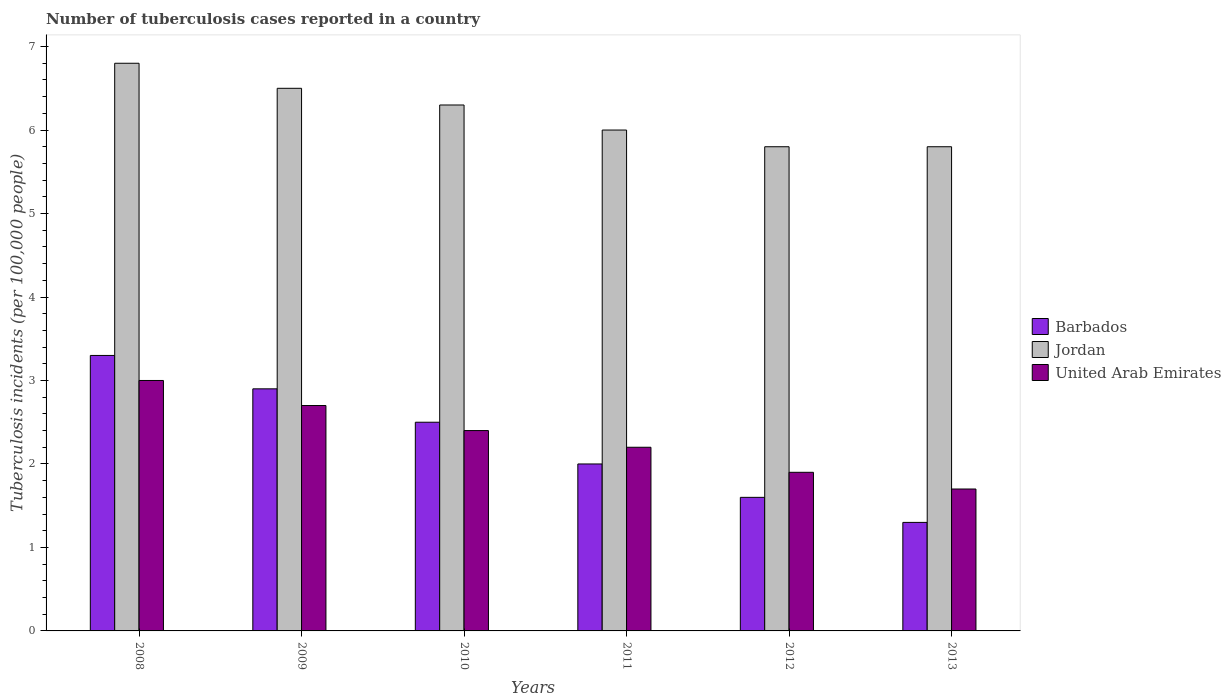How many different coloured bars are there?
Provide a succinct answer. 3. How many groups of bars are there?
Make the answer very short. 6. Are the number of bars per tick equal to the number of legend labels?
Keep it short and to the point. Yes. Are the number of bars on each tick of the X-axis equal?
Make the answer very short. Yes. How many bars are there on the 5th tick from the right?
Ensure brevity in your answer.  3. In how many cases, is the number of bars for a given year not equal to the number of legend labels?
Ensure brevity in your answer.  0. Across all years, what is the maximum number of tuberculosis cases reported in in Barbados?
Your answer should be compact. 3.3. Across all years, what is the minimum number of tuberculosis cases reported in in United Arab Emirates?
Give a very brief answer. 1.7. In which year was the number of tuberculosis cases reported in in United Arab Emirates maximum?
Give a very brief answer. 2008. In which year was the number of tuberculosis cases reported in in Jordan minimum?
Make the answer very short. 2012. What is the total number of tuberculosis cases reported in in Barbados in the graph?
Keep it short and to the point. 13.6. What is the difference between the number of tuberculosis cases reported in in Barbados in 2008 and that in 2012?
Ensure brevity in your answer.  1.7. What is the average number of tuberculosis cases reported in in Barbados per year?
Provide a short and direct response. 2.27. In how many years, is the number of tuberculosis cases reported in in Jordan greater than 4?
Keep it short and to the point. 6. What is the ratio of the number of tuberculosis cases reported in in Barbados in 2009 to that in 2012?
Your answer should be very brief. 1.81. Is the number of tuberculosis cases reported in in United Arab Emirates in 2010 less than that in 2013?
Your answer should be compact. No. Is the difference between the number of tuberculosis cases reported in in United Arab Emirates in 2009 and 2011 greater than the difference between the number of tuberculosis cases reported in in Jordan in 2009 and 2011?
Your answer should be very brief. No. What is the difference between the highest and the second highest number of tuberculosis cases reported in in Jordan?
Provide a short and direct response. 0.3. What does the 1st bar from the left in 2009 represents?
Keep it short and to the point. Barbados. What does the 2nd bar from the right in 2008 represents?
Provide a succinct answer. Jordan. Is it the case that in every year, the sum of the number of tuberculosis cases reported in in Barbados and number of tuberculosis cases reported in in United Arab Emirates is greater than the number of tuberculosis cases reported in in Jordan?
Keep it short and to the point. No. How many bars are there?
Offer a very short reply. 18. Are all the bars in the graph horizontal?
Offer a terse response. No. How many years are there in the graph?
Offer a terse response. 6. What is the difference between two consecutive major ticks on the Y-axis?
Provide a short and direct response. 1. Does the graph contain grids?
Provide a succinct answer. No. How many legend labels are there?
Your answer should be compact. 3. How are the legend labels stacked?
Your response must be concise. Vertical. What is the title of the graph?
Your answer should be very brief. Number of tuberculosis cases reported in a country. Does "St. Lucia" appear as one of the legend labels in the graph?
Keep it short and to the point. No. What is the label or title of the Y-axis?
Offer a very short reply. Tuberculosis incidents (per 100,0 people). What is the Tuberculosis incidents (per 100,000 people) in Barbados in 2008?
Give a very brief answer. 3.3. What is the Tuberculosis incidents (per 100,000 people) of Barbados in 2009?
Your answer should be very brief. 2.9. What is the Tuberculosis incidents (per 100,000 people) in United Arab Emirates in 2009?
Provide a short and direct response. 2.7. What is the Tuberculosis incidents (per 100,000 people) of Barbados in 2010?
Your answer should be compact. 2.5. What is the Tuberculosis incidents (per 100,000 people) of Jordan in 2010?
Make the answer very short. 6.3. What is the Tuberculosis incidents (per 100,000 people) of Barbados in 2011?
Provide a succinct answer. 2. What is the Tuberculosis incidents (per 100,000 people) of Jordan in 2011?
Your response must be concise. 6. Across all years, what is the maximum Tuberculosis incidents (per 100,000 people) of Barbados?
Provide a short and direct response. 3.3. Across all years, what is the maximum Tuberculosis incidents (per 100,000 people) in United Arab Emirates?
Ensure brevity in your answer.  3. Across all years, what is the minimum Tuberculosis incidents (per 100,000 people) of Barbados?
Offer a very short reply. 1.3. Across all years, what is the minimum Tuberculosis incidents (per 100,000 people) of United Arab Emirates?
Your answer should be very brief. 1.7. What is the total Tuberculosis incidents (per 100,000 people) in Jordan in the graph?
Your response must be concise. 37.2. What is the total Tuberculosis incidents (per 100,000 people) of United Arab Emirates in the graph?
Your response must be concise. 13.9. What is the difference between the Tuberculosis incidents (per 100,000 people) in Barbados in 2008 and that in 2009?
Make the answer very short. 0.4. What is the difference between the Tuberculosis incidents (per 100,000 people) of Barbados in 2008 and that in 2010?
Keep it short and to the point. 0.8. What is the difference between the Tuberculosis incidents (per 100,000 people) of United Arab Emirates in 2008 and that in 2010?
Offer a terse response. 0.6. What is the difference between the Tuberculosis incidents (per 100,000 people) of Barbados in 2008 and that in 2012?
Keep it short and to the point. 1.7. What is the difference between the Tuberculosis incidents (per 100,000 people) in Barbados in 2008 and that in 2013?
Your answer should be compact. 2. What is the difference between the Tuberculosis incidents (per 100,000 people) in Jordan in 2008 and that in 2013?
Provide a succinct answer. 1. What is the difference between the Tuberculosis incidents (per 100,000 people) of United Arab Emirates in 2009 and that in 2010?
Your answer should be very brief. 0.3. What is the difference between the Tuberculosis incidents (per 100,000 people) in Barbados in 2009 and that in 2011?
Your response must be concise. 0.9. What is the difference between the Tuberculosis incidents (per 100,000 people) in Jordan in 2009 and that in 2011?
Your response must be concise. 0.5. What is the difference between the Tuberculosis incidents (per 100,000 people) in United Arab Emirates in 2009 and that in 2011?
Provide a short and direct response. 0.5. What is the difference between the Tuberculosis incidents (per 100,000 people) in United Arab Emirates in 2009 and that in 2012?
Ensure brevity in your answer.  0.8. What is the difference between the Tuberculosis incidents (per 100,000 people) in Jordan in 2010 and that in 2011?
Ensure brevity in your answer.  0.3. What is the difference between the Tuberculosis incidents (per 100,000 people) in United Arab Emirates in 2010 and that in 2011?
Make the answer very short. 0.2. What is the difference between the Tuberculosis incidents (per 100,000 people) in Jordan in 2010 and that in 2012?
Your answer should be compact. 0.5. What is the difference between the Tuberculosis incidents (per 100,000 people) in United Arab Emirates in 2010 and that in 2012?
Keep it short and to the point. 0.5. What is the difference between the Tuberculosis incidents (per 100,000 people) in Barbados in 2010 and that in 2013?
Give a very brief answer. 1.2. What is the difference between the Tuberculosis incidents (per 100,000 people) in United Arab Emirates in 2010 and that in 2013?
Ensure brevity in your answer.  0.7. What is the difference between the Tuberculosis incidents (per 100,000 people) of Jordan in 2011 and that in 2012?
Provide a short and direct response. 0.2. What is the difference between the Tuberculosis incidents (per 100,000 people) in Barbados in 2012 and that in 2013?
Your response must be concise. 0.3. What is the difference between the Tuberculosis incidents (per 100,000 people) in Jordan in 2012 and that in 2013?
Give a very brief answer. 0. What is the difference between the Tuberculosis incidents (per 100,000 people) in United Arab Emirates in 2012 and that in 2013?
Provide a succinct answer. 0.2. What is the difference between the Tuberculosis incidents (per 100,000 people) of Barbados in 2008 and the Tuberculosis incidents (per 100,000 people) of United Arab Emirates in 2009?
Give a very brief answer. 0.6. What is the difference between the Tuberculosis incidents (per 100,000 people) of Jordan in 2008 and the Tuberculosis incidents (per 100,000 people) of United Arab Emirates in 2009?
Your answer should be very brief. 4.1. What is the difference between the Tuberculosis incidents (per 100,000 people) of Barbados in 2008 and the Tuberculosis incidents (per 100,000 people) of Jordan in 2010?
Provide a short and direct response. -3. What is the difference between the Tuberculosis incidents (per 100,000 people) of Barbados in 2008 and the Tuberculosis incidents (per 100,000 people) of United Arab Emirates in 2010?
Give a very brief answer. 0.9. What is the difference between the Tuberculosis incidents (per 100,000 people) of Jordan in 2008 and the Tuberculosis incidents (per 100,000 people) of United Arab Emirates in 2010?
Keep it short and to the point. 4.4. What is the difference between the Tuberculosis incidents (per 100,000 people) of Barbados in 2008 and the Tuberculosis incidents (per 100,000 people) of United Arab Emirates in 2011?
Make the answer very short. 1.1. What is the difference between the Tuberculosis incidents (per 100,000 people) of Jordan in 2008 and the Tuberculosis incidents (per 100,000 people) of United Arab Emirates in 2011?
Offer a very short reply. 4.6. What is the difference between the Tuberculosis incidents (per 100,000 people) in Barbados in 2008 and the Tuberculosis incidents (per 100,000 people) in Jordan in 2012?
Your response must be concise. -2.5. What is the difference between the Tuberculosis incidents (per 100,000 people) in Jordan in 2008 and the Tuberculosis incidents (per 100,000 people) in United Arab Emirates in 2012?
Offer a very short reply. 4.9. What is the difference between the Tuberculosis incidents (per 100,000 people) of Barbados in 2008 and the Tuberculosis incidents (per 100,000 people) of Jordan in 2013?
Keep it short and to the point. -2.5. What is the difference between the Tuberculosis incidents (per 100,000 people) of Barbados in 2008 and the Tuberculosis incidents (per 100,000 people) of United Arab Emirates in 2013?
Keep it short and to the point. 1.6. What is the difference between the Tuberculosis incidents (per 100,000 people) of Barbados in 2009 and the Tuberculosis incidents (per 100,000 people) of United Arab Emirates in 2010?
Keep it short and to the point. 0.5. What is the difference between the Tuberculosis incidents (per 100,000 people) of Jordan in 2009 and the Tuberculosis incidents (per 100,000 people) of United Arab Emirates in 2010?
Keep it short and to the point. 4.1. What is the difference between the Tuberculosis incidents (per 100,000 people) of Barbados in 2009 and the Tuberculosis incidents (per 100,000 people) of Jordan in 2012?
Offer a terse response. -2.9. What is the difference between the Tuberculosis incidents (per 100,000 people) in Jordan in 2009 and the Tuberculosis incidents (per 100,000 people) in United Arab Emirates in 2012?
Your response must be concise. 4.6. What is the difference between the Tuberculosis incidents (per 100,000 people) in Barbados in 2009 and the Tuberculosis incidents (per 100,000 people) in Jordan in 2013?
Give a very brief answer. -2.9. What is the difference between the Tuberculosis incidents (per 100,000 people) of Barbados in 2010 and the Tuberculosis incidents (per 100,000 people) of United Arab Emirates in 2011?
Ensure brevity in your answer.  0.3. What is the difference between the Tuberculosis incidents (per 100,000 people) of Jordan in 2010 and the Tuberculosis incidents (per 100,000 people) of United Arab Emirates in 2011?
Provide a short and direct response. 4.1. What is the difference between the Tuberculosis incidents (per 100,000 people) in Barbados in 2010 and the Tuberculosis incidents (per 100,000 people) in Jordan in 2012?
Your answer should be compact. -3.3. What is the difference between the Tuberculosis incidents (per 100,000 people) in Barbados in 2010 and the Tuberculosis incidents (per 100,000 people) in United Arab Emirates in 2012?
Your response must be concise. 0.6. What is the difference between the Tuberculosis incidents (per 100,000 people) of Barbados in 2010 and the Tuberculosis incidents (per 100,000 people) of Jordan in 2013?
Provide a succinct answer. -3.3. What is the difference between the Tuberculosis incidents (per 100,000 people) in Barbados in 2010 and the Tuberculosis incidents (per 100,000 people) in United Arab Emirates in 2013?
Ensure brevity in your answer.  0.8. What is the difference between the Tuberculosis incidents (per 100,000 people) of Barbados in 2011 and the Tuberculosis incidents (per 100,000 people) of Jordan in 2012?
Your answer should be compact. -3.8. What is the difference between the Tuberculosis incidents (per 100,000 people) in Barbados in 2011 and the Tuberculosis incidents (per 100,000 people) in Jordan in 2013?
Your response must be concise. -3.8. What is the difference between the Tuberculosis incidents (per 100,000 people) in Barbados in 2011 and the Tuberculosis incidents (per 100,000 people) in United Arab Emirates in 2013?
Ensure brevity in your answer.  0.3. What is the difference between the Tuberculosis incidents (per 100,000 people) in Barbados in 2012 and the Tuberculosis incidents (per 100,000 people) in Jordan in 2013?
Provide a succinct answer. -4.2. What is the difference between the Tuberculosis incidents (per 100,000 people) of Barbados in 2012 and the Tuberculosis incidents (per 100,000 people) of United Arab Emirates in 2013?
Keep it short and to the point. -0.1. What is the average Tuberculosis incidents (per 100,000 people) in Barbados per year?
Your answer should be compact. 2.27. What is the average Tuberculosis incidents (per 100,000 people) in Jordan per year?
Keep it short and to the point. 6.2. What is the average Tuberculosis incidents (per 100,000 people) in United Arab Emirates per year?
Your answer should be very brief. 2.32. In the year 2008, what is the difference between the Tuberculosis incidents (per 100,000 people) of Barbados and Tuberculosis incidents (per 100,000 people) of Jordan?
Your response must be concise. -3.5. In the year 2010, what is the difference between the Tuberculosis incidents (per 100,000 people) of Barbados and Tuberculosis incidents (per 100,000 people) of Jordan?
Your answer should be very brief. -3.8. In the year 2010, what is the difference between the Tuberculosis incidents (per 100,000 people) of Jordan and Tuberculosis incidents (per 100,000 people) of United Arab Emirates?
Your response must be concise. 3.9. In the year 2011, what is the difference between the Tuberculosis incidents (per 100,000 people) of Barbados and Tuberculosis incidents (per 100,000 people) of Jordan?
Your answer should be very brief. -4. In the year 2011, what is the difference between the Tuberculosis incidents (per 100,000 people) in Jordan and Tuberculosis incidents (per 100,000 people) in United Arab Emirates?
Provide a short and direct response. 3.8. In the year 2012, what is the difference between the Tuberculosis incidents (per 100,000 people) in Jordan and Tuberculosis incidents (per 100,000 people) in United Arab Emirates?
Your response must be concise. 3.9. In the year 2013, what is the difference between the Tuberculosis incidents (per 100,000 people) of Barbados and Tuberculosis incidents (per 100,000 people) of Jordan?
Offer a very short reply. -4.5. In the year 2013, what is the difference between the Tuberculosis incidents (per 100,000 people) in Jordan and Tuberculosis incidents (per 100,000 people) in United Arab Emirates?
Give a very brief answer. 4.1. What is the ratio of the Tuberculosis incidents (per 100,000 people) in Barbados in 2008 to that in 2009?
Your answer should be compact. 1.14. What is the ratio of the Tuberculosis incidents (per 100,000 people) of Jordan in 2008 to that in 2009?
Provide a short and direct response. 1.05. What is the ratio of the Tuberculosis incidents (per 100,000 people) of Barbados in 2008 to that in 2010?
Your answer should be compact. 1.32. What is the ratio of the Tuberculosis incidents (per 100,000 people) in Jordan in 2008 to that in 2010?
Ensure brevity in your answer.  1.08. What is the ratio of the Tuberculosis incidents (per 100,000 people) in Barbados in 2008 to that in 2011?
Make the answer very short. 1.65. What is the ratio of the Tuberculosis incidents (per 100,000 people) of Jordan in 2008 to that in 2011?
Your answer should be very brief. 1.13. What is the ratio of the Tuberculosis incidents (per 100,000 people) in United Arab Emirates in 2008 to that in 2011?
Give a very brief answer. 1.36. What is the ratio of the Tuberculosis incidents (per 100,000 people) in Barbados in 2008 to that in 2012?
Provide a short and direct response. 2.06. What is the ratio of the Tuberculosis incidents (per 100,000 people) in Jordan in 2008 to that in 2012?
Give a very brief answer. 1.17. What is the ratio of the Tuberculosis incidents (per 100,000 people) in United Arab Emirates in 2008 to that in 2012?
Offer a terse response. 1.58. What is the ratio of the Tuberculosis incidents (per 100,000 people) in Barbados in 2008 to that in 2013?
Make the answer very short. 2.54. What is the ratio of the Tuberculosis incidents (per 100,000 people) of Jordan in 2008 to that in 2013?
Your answer should be compact. 1.17. What is the ratio of the Tuberculosis incidents (per 100,000 people) in United Arab Emirates in 2008 to that in 2013?
Keep it short and to the point. 1.76. What is the ratio of the Tuberculosis incidents (per 100,000 people) in Barbados in 2009 to that in 2010?
Keep it short and to the point. 1.16. What is the ratio of the Tuberculosis incidents (per 100,000 people) in Jordan in 2009 to that in 2010?
Your response must be concise. 1.03. What is the ratio of the Tuberculosis incidents (per 100,000 people) of Barbados in 2009 to that in 2011?
Provide a short and direct response. 1.45. What is the ratio of the Tuberculosis incidents (per 100,000 people) in Jordan in 2009 to that in 2011?
Offer a very short reply. 1.08. What is the ratio of the Tuberculosis incidents (per 100,000 people) in United Arab Emirates in 2009 to that in 2011?
Keep it short and to the point. 1.23. What is the ratio of the Tuberculosis incidents (per 100,000 people) of Barbados in 2009 to that in 2012?
Offer a very short reply. 1.81. What is the ratio of the Tuberculosis incidents (per 100,000 people) of Jordan in 2009 to that in 2012?
Ensure brevity in your answer.  1.12. What is the ratio of the Tuberculosis incidents (per 100,000 people) of United Arab Emirates in 2009 to that in 2012?
Your answer should be very brief. 1.42. What is the ratio of the Tuberculosis incidents (per 100,000 people) in Barbados in 2009 to that in 2013?
Ensure brevity in your answer.  2.23. What is the ratio of the Tuberculosis incidents (per 100,000 people) in Jordan in 2009 to that in 2013?
Offer a terse response. 1.12. What is the ratio of the Tuberculosis incidents (per 100,000 people) of United Arab Emirates in 2009 to that in 2013?
Offer a very short reply. 1.59. What is the ratio of the Tuberculosis incidents (per 100,000 people) of Barbados in 2010 to that in 2011?
Give a very brief answer. 1.25. What is the ratio of the Tuberculosis incidents (per 100,000 people) in Jordan in 2010 to that in 2011?
Your answer should be compact. 1.05. What is the ratio of the Tuberculosis incidents (per 100,000 people) in United Arab Emirates in 2010 to that in 2011?
Offer a very short reply. 1.09. What is the ratio of the Tuberculosis incidents (per 100,000 people) of Barbados in 2010 to that in 2012?
Your answer should be very brief. 1.56. What is the ratio of the Tuberculosis incidents (per 100,000 people) in Jordan in 2010 to that in 2012?
Give a very brief answer. 1.09. What is the ratio of the Tuberculosis incidents (per 100,000 people) of United Arab Emirates in 2010 to that in 2012?
Give a very brief answer. 1.26. What is the ratio of the Tuberculosis incidents (per 100,000 people) in Barbados in 2010 to that in 2013?
Your answer should be very brief. 1.92. What is the ratio of the Tuberculosis incidents (per 100,000 people) in Jordan in 2010 to that in 2013?
Provide a succinct answer. 1.09. What is the ratio of the Tuberculosis incidents (per 100,000 people) of United Arab Emirates in 2010 to that in 2013?
Ensure brevity in your answer.  1.41. What is the ratio of the Tuberculosis incidents (per 100,000 people) of Barbados in 2011 to that in 2012?
Your answer should be compact. 1.25. What is the ratio of the Tuberculosis incidents (per 100,000 people) of Jordan in 2011 to that in 2012?
Your response must be concise. 1.03. What is the ratio of the Tuberculosis incidents (per 100,000 people) of United Arab Emirates in 2011 to that in 2012?
Ensure brevity in your answer.  1.16. What is the ratio of the Tuberculosis incidents (per 100,000 people) of Barbados in 2011 to that in 2013?
Provide a succinct answer. 1.54. What is the ratio of the Tuberculosis incidents (per 100,000 people) of Jordan in 2011 to that in 2013?
Provide a short and direct response. 1.03. What is the ratio of the Tuberculosis incidents (per 100,000 people) in United Arab Emirates in 2011 to that in 2013?
Offer a terse response. 1.29. What is the ratio of the Tuberculosis incidents (per 100,000 people) in Barbados in 2012 to that in 2013?
Your response must be concise. 1.23. What is the ratio of the Tuberculosis incidents (per 100,000 people) in United Arab Emirates in 2012 to that in 2013?
Offer a terse response. 1.12. What is the difference between the highest and the second highest Tuberculosis incidents (per 100,000 people) in Barbados?
Offer a terse response. 0.4. What is the difference between the highest and the second highest Tuberculosis incidents (per 100,000 people) in Jordan?
Provide a short and direct response. 0.3. What is the difference between the highest and the second highest Tuberculosis incidents (per 100,000 people) of United Arab Emirates?
Your answer should be compact. 0.3. What is the difference between the highest and the lowest Tuberculosis incidents (per 100,000 people) of Jordan?
Keep it short and to the point. 1. What is the difference between the highest and the lowest Tuberculosis incidents (per 100,000 people) in United Arab Emirates?
Your answer should be very brief. 1.3. 